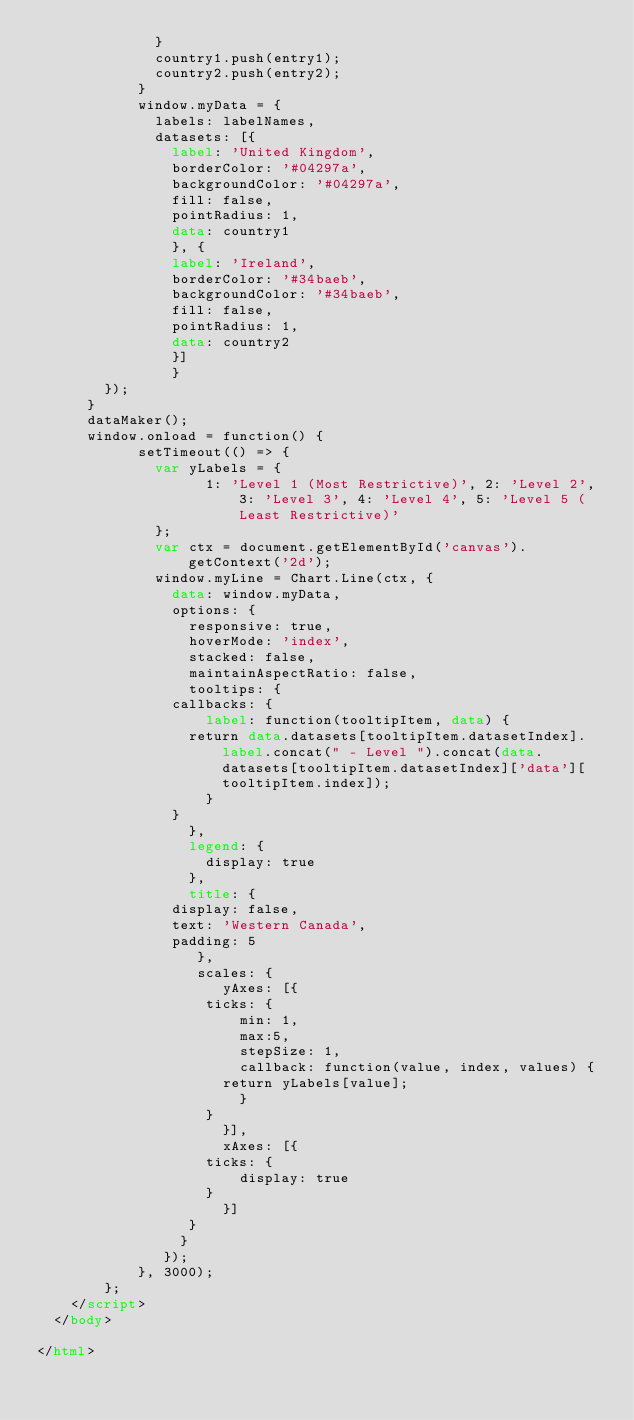<code> <loc_0><loc_0><loc_500><loc_500><_HTML_>						  }
						  country1.push(entry1);
						  country2.push(entry2);
					  }
					  window.myData = {
						  labels: labelNames,
						  datasets: [{
						    label: 'United Kingdom',
						    borderColor: '#04297a',
						    backgroundColor: '#04297a',
						    fill: false,
						    pointRadius: 1,
						    data: country1
						    }, {
						    label: 'Ireland',
						    borderColor: '#34baeb',
						    backgroundColor: '#34baeb',
						    fill: false,
						    pointRadius: 1,
						    data: country2
						    }]
						    }  
				});
			}
			dataMaker();
			window.onload = function() {
						setTimeout(() => { 
							var yLabels = {
							      1: 'Level 1 (Most Restrictive)', 2: 'Level 2', 3: 'Level 3', 4: 'Level 4', 5: 'Level 5 (Least Restrictive)'
							};
							var ctx = document.getElementById('canvas').getContext('2d');
							window.myLine = Chart.Line(ctx, {
							  data: window.myData,
							  options: {
							    responsive: true,
							    hoverMode: 'index',
							    stacked: false,
							    maintainAspectRatio: false,
							    tooltips: {
								callbacks: {
								    label: function(tooltipItem, data) {
									return data.datasets[tooltipItem.datasetIndex].label.concat(" - Level ").concat(data.datasets[tooltipItem.datasetIndex]['data'][tooltipItem.index]);
								    }
								}
							    },
							    legend: {
								    display: true
							    },
							    title: {
								display: false,
								text: 'Western Canada',
								padding: 5
							     },
							     scales: {
								      yAxes: [{
									  ticks: {
									      min: 1,
									      max:5,
									      stepSize: 1,
									      callback: function(value, index, values) {
										  return yLabels[value];
									      }
									  }
								      }],
								      xAxes: [{
									  ticks: {
									      display: true
									  }
								      }]
								  }
							   }
							 });
						}, 3000);
				};
		</script>
	</body>

</html></code> 